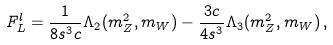<formula> <loc_0><loc_0><loc_500><loc_500>F _ { L } ^ { l } = \frac { 1 } { 8 s ^ { 3 } c } \Lambda _ { 2 } ( m _ { Z } ^ { 2 } , m _ { W } ) - \frac { 3 c } { 4 s ^ { 3 } } \Lambda _ { 3 } ( m _ { Z } ^ { 2 } , m _ { W } ) \, ,</formula> 